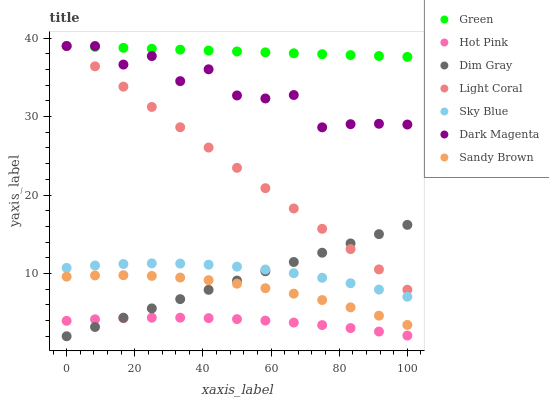Does Hot Pink have the minimum area under the curve?
Answer yes or no. Yes. Does Green have the maximum area under the curve?
Answer yes or no. Yes. Does Dark Magenta have the minimum area under the curve?
Answer yes or no. No. Does Dark Magenta have the maximum area under the curve?
Answer yes or no. No. Is Dim Gray the smoothest?
Answer yes or no. Yes. Is Dark Magenta the roughest?
Answer yes or no. Yes. Is Hot Pink the smoothest?
Answer yes or no. No. Is Hot Pink the roughest?
Answer yes or no. No. Does Dim Gray have the lowest value?
Answer yes or no. Yes. Does Dark Magenta have the lowest value?
Answer yes or no. No. Does Green have the highest value?
Answer yes or no. Yes. Does Hot Pink have the highest value?
Answer yes or no. No. Is Sky Blue less than Green?
Answer yes or no. Yes. Is Green greater than Sky Blue?
Answer yes or no. Yes. Does Dim Gray intersect Light Coral?
Answer yes or no. Yes. Is Dim Gray less than Light Coral?
Answer yes or no. No. Is Dim Gray greater than Light Coral?
Answer yes or no. No. Does Sky Blue intersect Green?
Answer yes or no. No. 